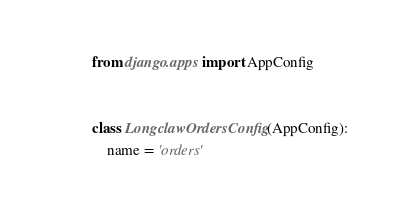<code> <loc_0><loc_0><loc_500><loc_500><_Python_>from django.apps import AppConfig


class LongclawOrdersConfig(AppConfig):
    name = 'orders'
</code> 